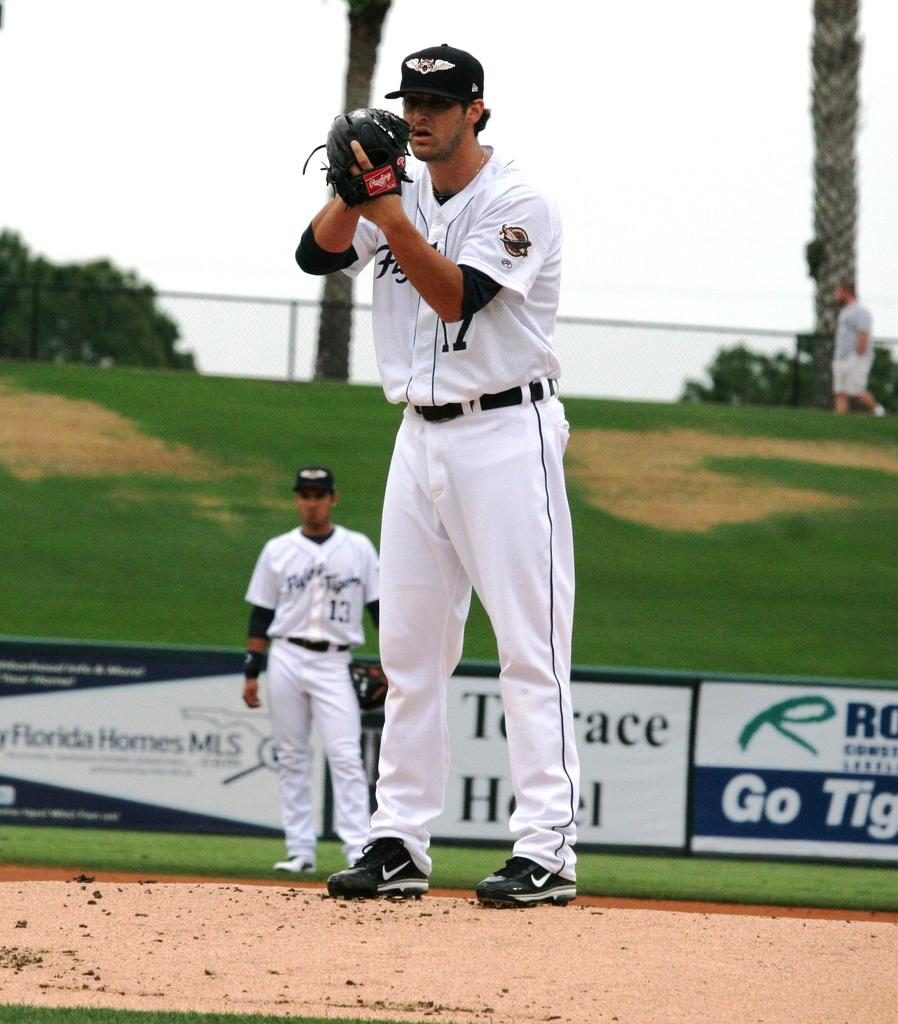<image>
Offer a succinct explanation of the picture presented. An advertisement with the word go on it is near a baseball field. 